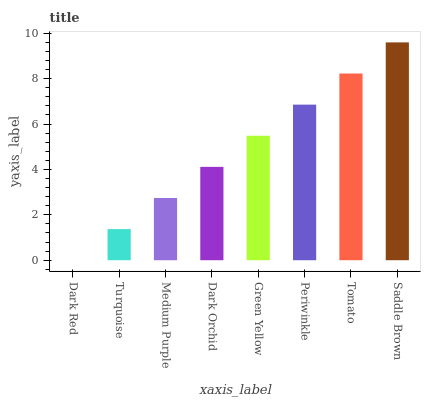Is Dark Red the minimum?
Answer yes or no. Yes. Is Saddle Brown the maximum?
Answer yes or no. Yes. Is Turquoise the minimum?
Answer yes or no. No. Is Turquoise the maximum?
Answer yes or no. No. Is Turquoise greater than Dark Red?
Answer yes or no. Yes. Is Dark Red less than Turquoise?
Answer yes or no. Yes. Is Dark Red greater than Turquoise?
Answer yes or no. No. Is Turquoise less than Dark Red?
Answer yes or no. No. Is Green Yellow the high median?
Answer yes or no. Yes. Is Dark Orchid the low median?
Answer yes or no. Yes. Is Turquoise the high median?
Answer yes or no. No. Is Tomato the low median?
Answer yes or no. No. 